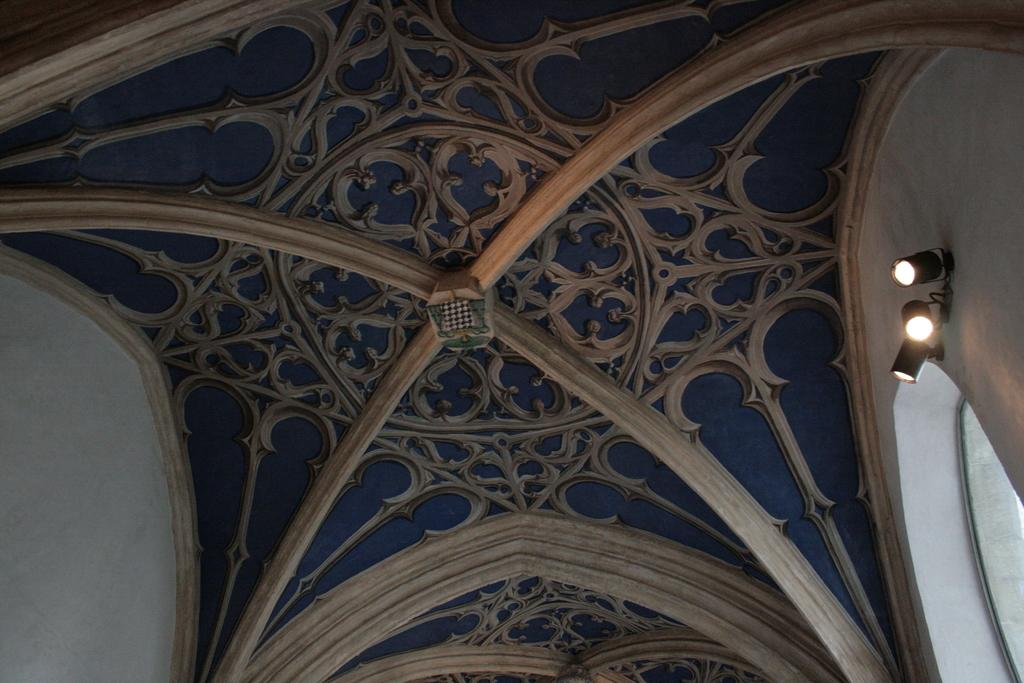How many lights are visible in the image? There are three lights in the image. What other architectural feature can be seen in the image? There is a window in the image. Can you describe the roof in the image? The roof in the image has a design. How many eyes can be seen on the ant in the image? There is no ant present in the image, so it is not possible to determine the number of eyes on an ant. 